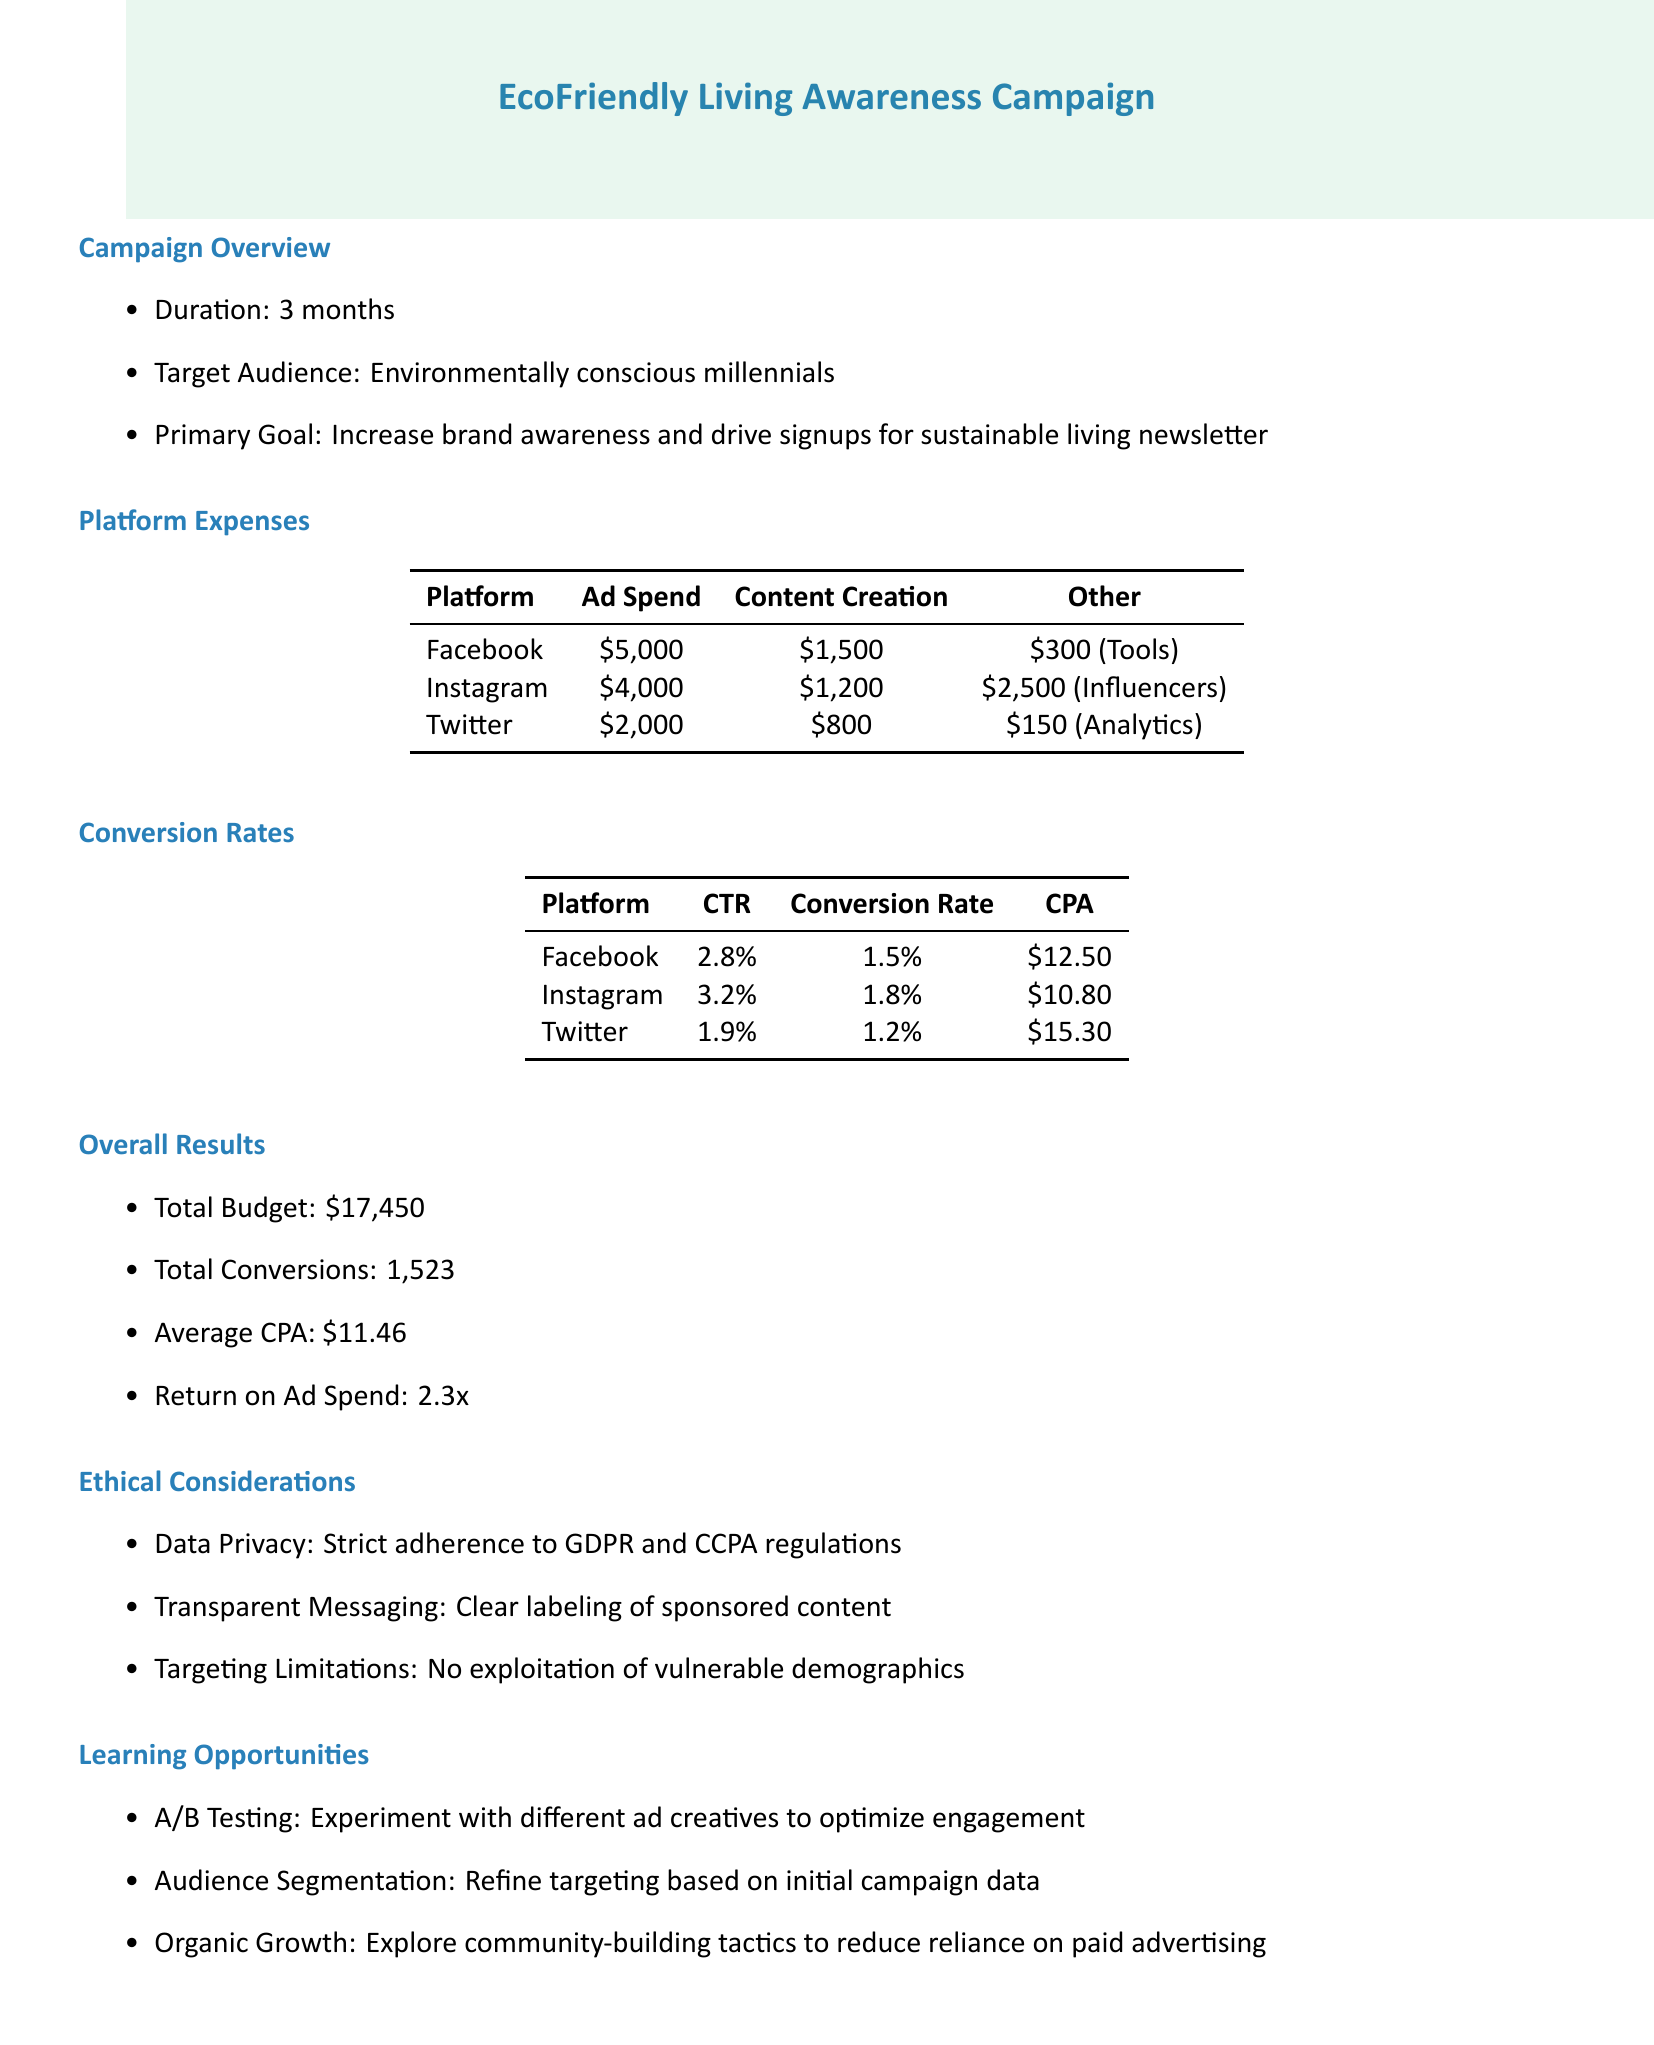What is the name of the campaign? The document states the campaign name clearly as "EcoFriendly Living Awareness."
Answer: EcoFriendly Living Awareness How long did the campaign run? The duration of the campaign is mentioned as "3 months."
Answer: 3 months What was the total budget for the campaign? The total budget figure provided in the document is "$17,450."
Answer: $17,450 What is the average cost per acquisition? The average cost per acquisition, noted in the overall results, is "$11.46."
Answer: $11.46 Which platform had the highest ad spend? By comparing the ad spend for each platform, Instagram shows the highest figure listed as "$4,000."
Answer: Instagram What is the click-through rate for Facebook? The document specifies the click-through rate for Facebook as "2.8%."
Answer: 2.8% Which platform had the lowest conversion rate? The conversion rates across platforms indicate Twitter had the lowest at "1.2%."
Answer: 1.2% What ethical guideline relates to data privacy? The document mentions strict adherence to GDPR and CCPA regulations under ethical considerations.
Answer: GDPR and CCPA What learning opportunity involves testing ad creatives? The document provides "A/B Testing" as a method to experiment with different ad creatives.
Answer: A/B Testing 